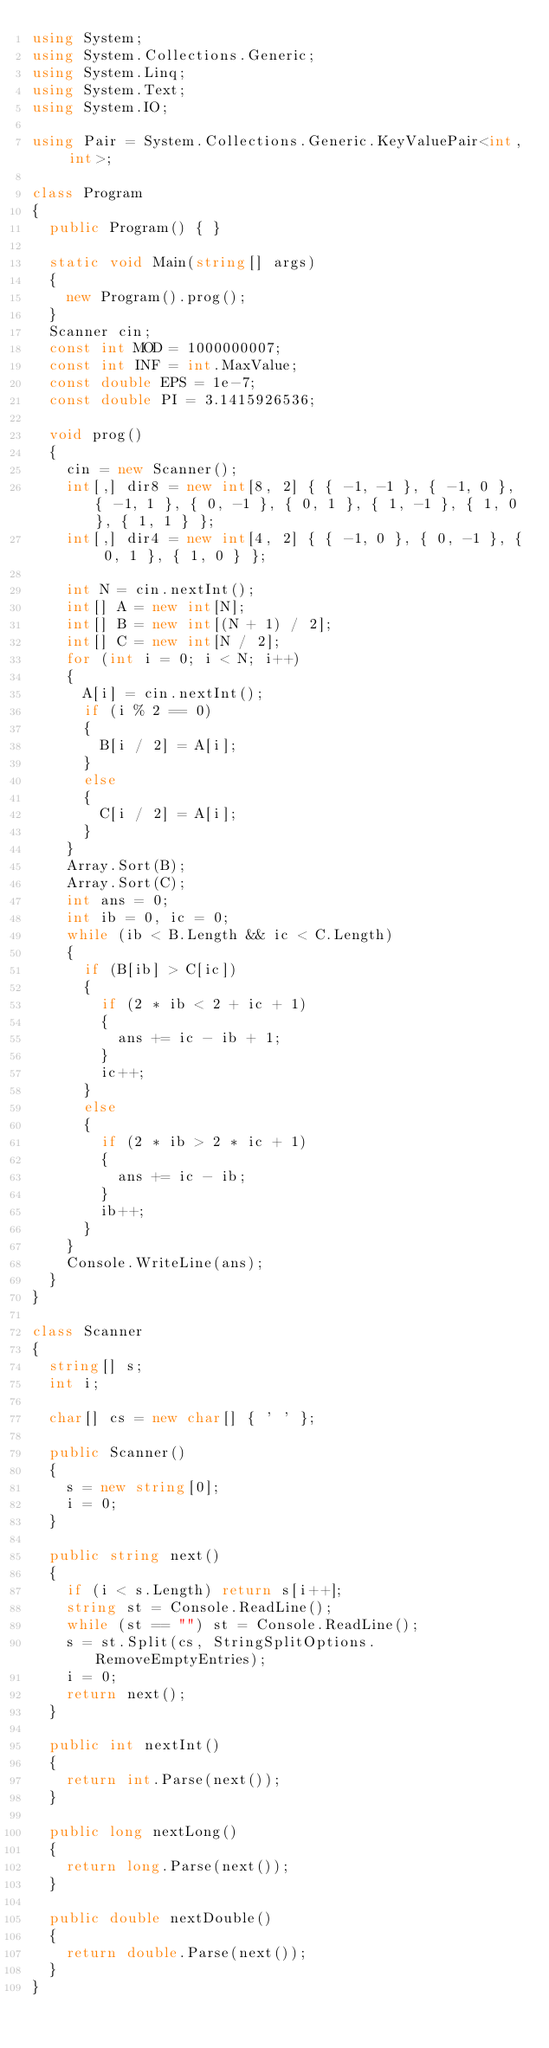<code> <loc_0><loc_0><loc_500><loc_500><_C#_>using System;
using System.Collections.Generic;
using System.Linq;
using System.Text;
using System.IO;

using Pair = System.Collections.Generic.KeyValuePair<int, int>;

class Program
{
	public Program() { }

	static void Main(string[] args)
	{
		new Program().prog();
	}
	Scanner cin;
	const int MOD = 1000000007;
	const int INF = int.MaxValue;
	const double EPS = 1e-7;
	const double PI = 3.1415926536;

	void prog()
	{
		cin = new Scanner();
		int[,] dir8 = new int[8, 2] { { -1, -1 }, { -1, 0 }, { -1, 1 }, { 0, -1 }, { 0, 1 }, { 1, -1 }, { 1, 0 }, { 1, 1 } };
		int[,] dir4 = new int[4, 2] { { -1, 0 }, { 0, -1 }, { 0, 1 }, { 1, 0 } };

		int N = cin.nextInt();
		int[] A = new int[N];
		int[] B = new int[(N + 1) / 2];
		int[] C = new int[N / 2];
		for (int i = 0; i < N; i++)
		{
			A[i] = cin.nextInt();
			if (i % 2 == 0)
			{
				B[i / 2] = A[i];
			}
			else
			{
				C[i / 2] = A[i];
			}
		}
		Array.Sort(B);
		Array.Sort(C);
		int ans = 0;
		int ib = 0, ic = 0;
		while (ib < B.Length && ic < C.Length)
		{
			if (B[ib] > C[ic])
			{
				if (2 * ib < 2 + ic + 1)
				{
					ans += ic - ib + 1;
				}
				ic++;
			}
			else
			{
				if (2 * ib > 2 * ic + 1)
				{
					ans += ic - ib;
				}
				ib++;
			}
		}
		Console.WriteLine(ans);
	}
}

class Scanner
{
	string[] s;
	int i;

	char[] cs = new char[] { ' ' };

	public Scanner()
	{
		s = new string[0];
		i = 0;
	}

	public string next()
	{
		if (i < s.Length) return s[i++];
		string st = Console.ReadLine();
		while (st == "") st = Console.ReadLine();
		s = st.Split(cs, StringSplitOptions.RemoveEmptyEntries);
		i = 0;
		return next();
	}

	public int nextInt()
	{
		return int.Parse(next());
	}

	public long nextLong()
	{
		return long.Parse(next());
	}

	public double nextDouble()
	{
		return double.Parse(next());
	}
}</code> 